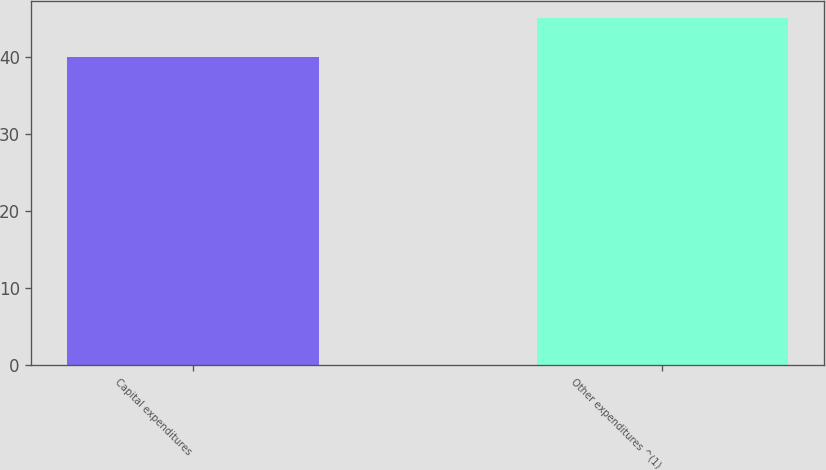Convert chart to OTSL. <chart><loc_0><loc_0><loc_500><loc_500><bar_chart><fcel>Capital expenditures<fcel>Other expenditures ^(1)<nl><fcel>40<fcel>45<nl></chart> 